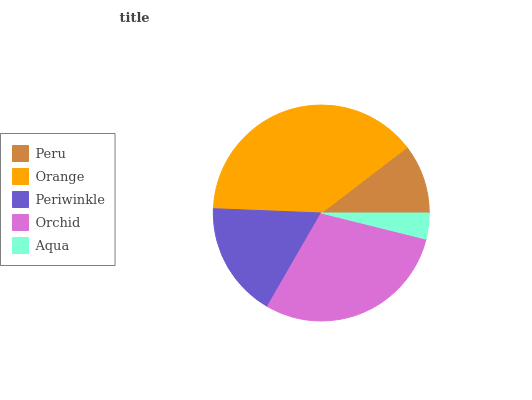Is Aqua the minimum?
Answer yes or no. Yes. Is Orange the maximum?
Answer yes or no. Yes. Is Periwinkle the minimum?
Answer yes or no. No. Is Periwinkle the maximum?
Answer yes or no. No. Is Orange greater than Periwinkle?
Answer yes or no. Yes. Is Periwinkle less than Orange?
Answer yes or no. Yes. Is Periwinkle greater than Orange?
Answer yes or no. No. Is Orange less than Periwinkle?
Answer yes or no. No. Is Periwinkle the high median?
Answer yes or no. Yes. Is Periwinkle the low median?
Answer yes or no. Yes. Is Aqua the high median?
Answer yes or no. No. Is Aqua the low median?
Answer yes or no. No. 